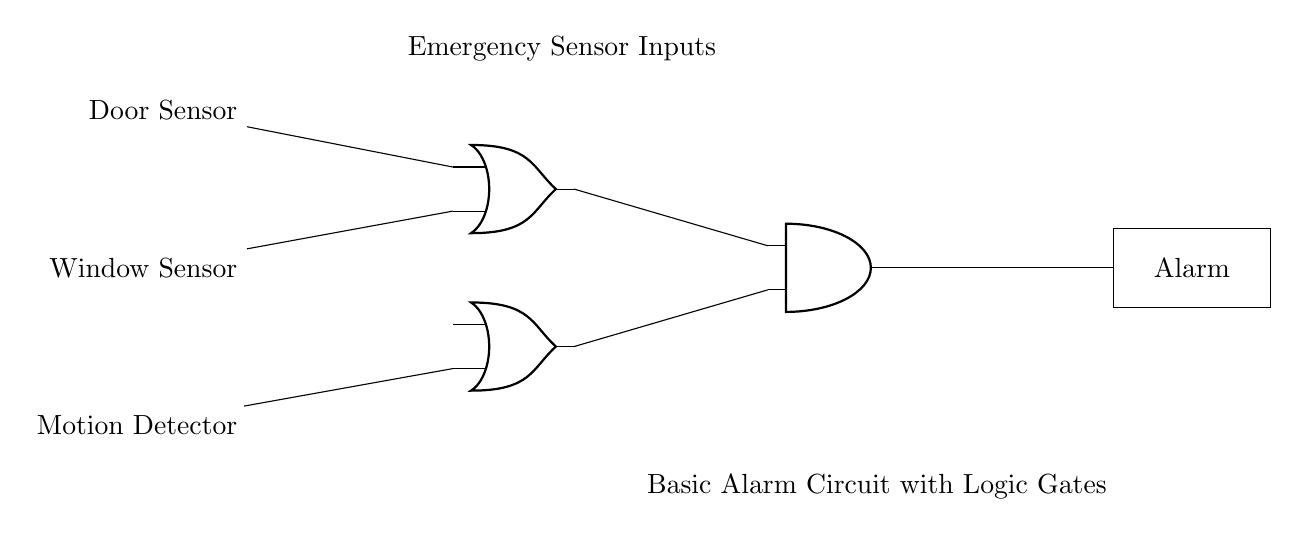What are the input components in the circuit? The input components are the door sensor, window sensor, and motion detector. They are the devices that provide signals to the logic gates.
Answer: door sensor, window sensor, motion detector How many OR gates are present in this circuit? There are two OR gates in the circuit, as indicated by the symbols in the diagram. Each OR gate combines two inputs.
Answer: 2 What is the type of the final output component? The final output component is a rectangle labeled "Alarm," which signifies an alert mechanism triggered by the logic gates.
Answer: Alarm What is the function of the AND gate in this circuit? The AND gate receives outputs from the OR gates. Its function is to ensure that both conditions from the OR gates must be true for the alarm to be activated.
Answer: Logical conjunction What must happen for the alarm to activate? For the alarm to activate, at least one input from the first OR gate and one input from the second OR gate must be true (activated). This means that either the door/window sensor or the motion detector must sense an event.
Answer: At least one true input from each OR gate If the window sensor is activated, what happens to the alarm output? If the window sensor is activated, it provides an input to the first OR gate. If the other conditions are satisfied (another input from the second OR gate), the AND gate will allow the output to reach the alarm.
Answer: Depends on conditions 